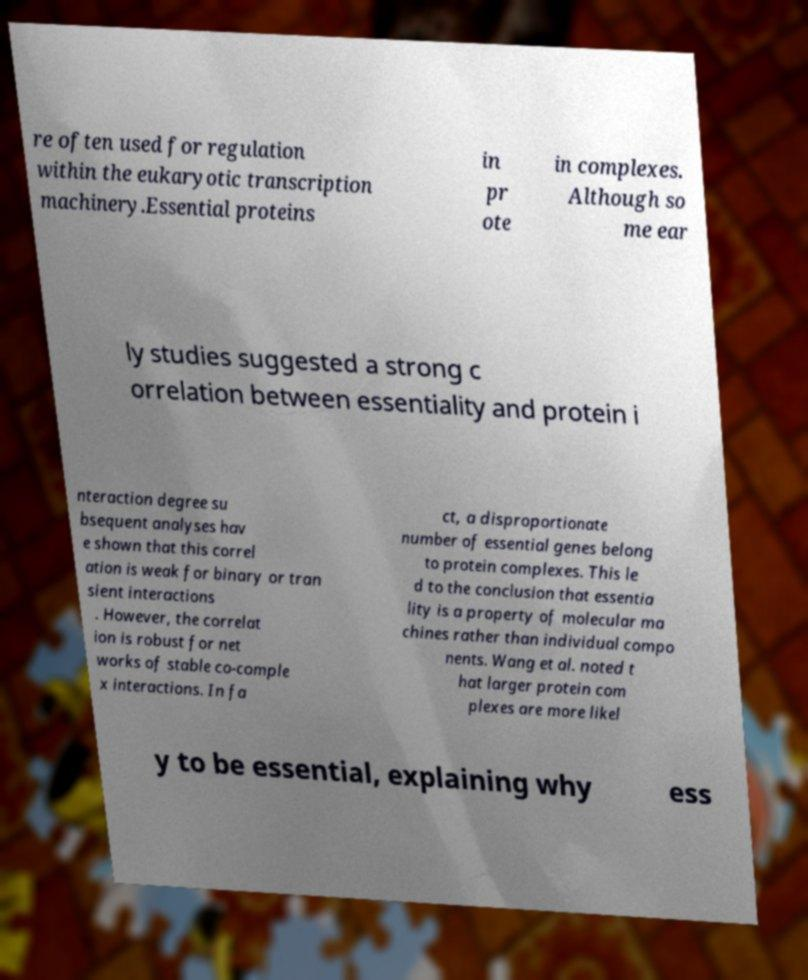Could you assist in decoding the text presented in this image and type it out clearly? re often used for regulation within the eukaryotic transcription machinery.Essential proteins in pr ote in complexes. Although so me ear ly studies suggested a strong c orrelation between essentiality and protein i nteraction degree su bsequent analyses hav e shown that this correl ation is weak for binary or tran sient interactions . However, the correlat ion is robust for net works of stable co-comple x interactions. In fa ct, a disproportionate number of essential genes belong to protein complexes. This le d to the conclusion that essentia lity is a property of molecular ma chines rather than individual compo nents. Wang et al. noted t hat larger protein com plexes are more likel y to be essential, explaining why ess 